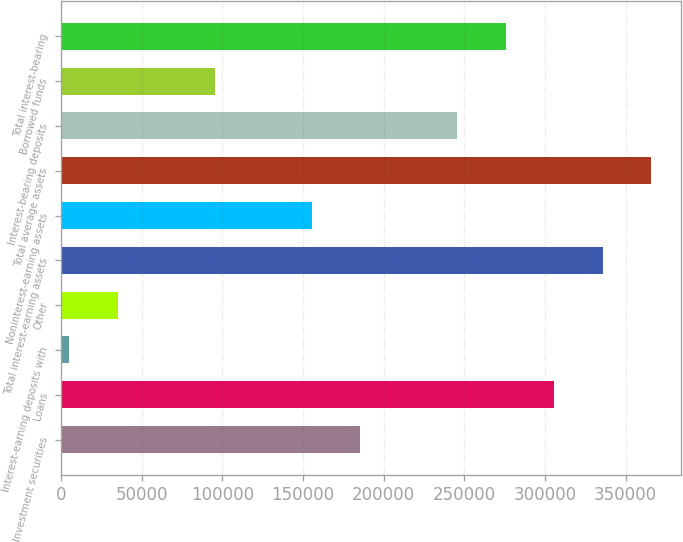<chart> <loc_0><loc_0><loc_500><loc_500><bar_chart><fcel>Investment securities<fcel>Loans<fcel>Interest-earning deposits with<fcel>Other<fcel>Total interest-earning assets<fcel>Noninterest-earning assets<fcel>Total average assets<fcel>Interest-bearing deposits<fcel>Borrowed funds<fcel>Total interest-bearing<nl><fcel>185362<fcel>305664<fcel>4910<fcel>34985.4<fcel>335739<fcel>155287<fcel>365815<fcel>245513<fcel>95136.2<fcel>275589<nl></chart> 